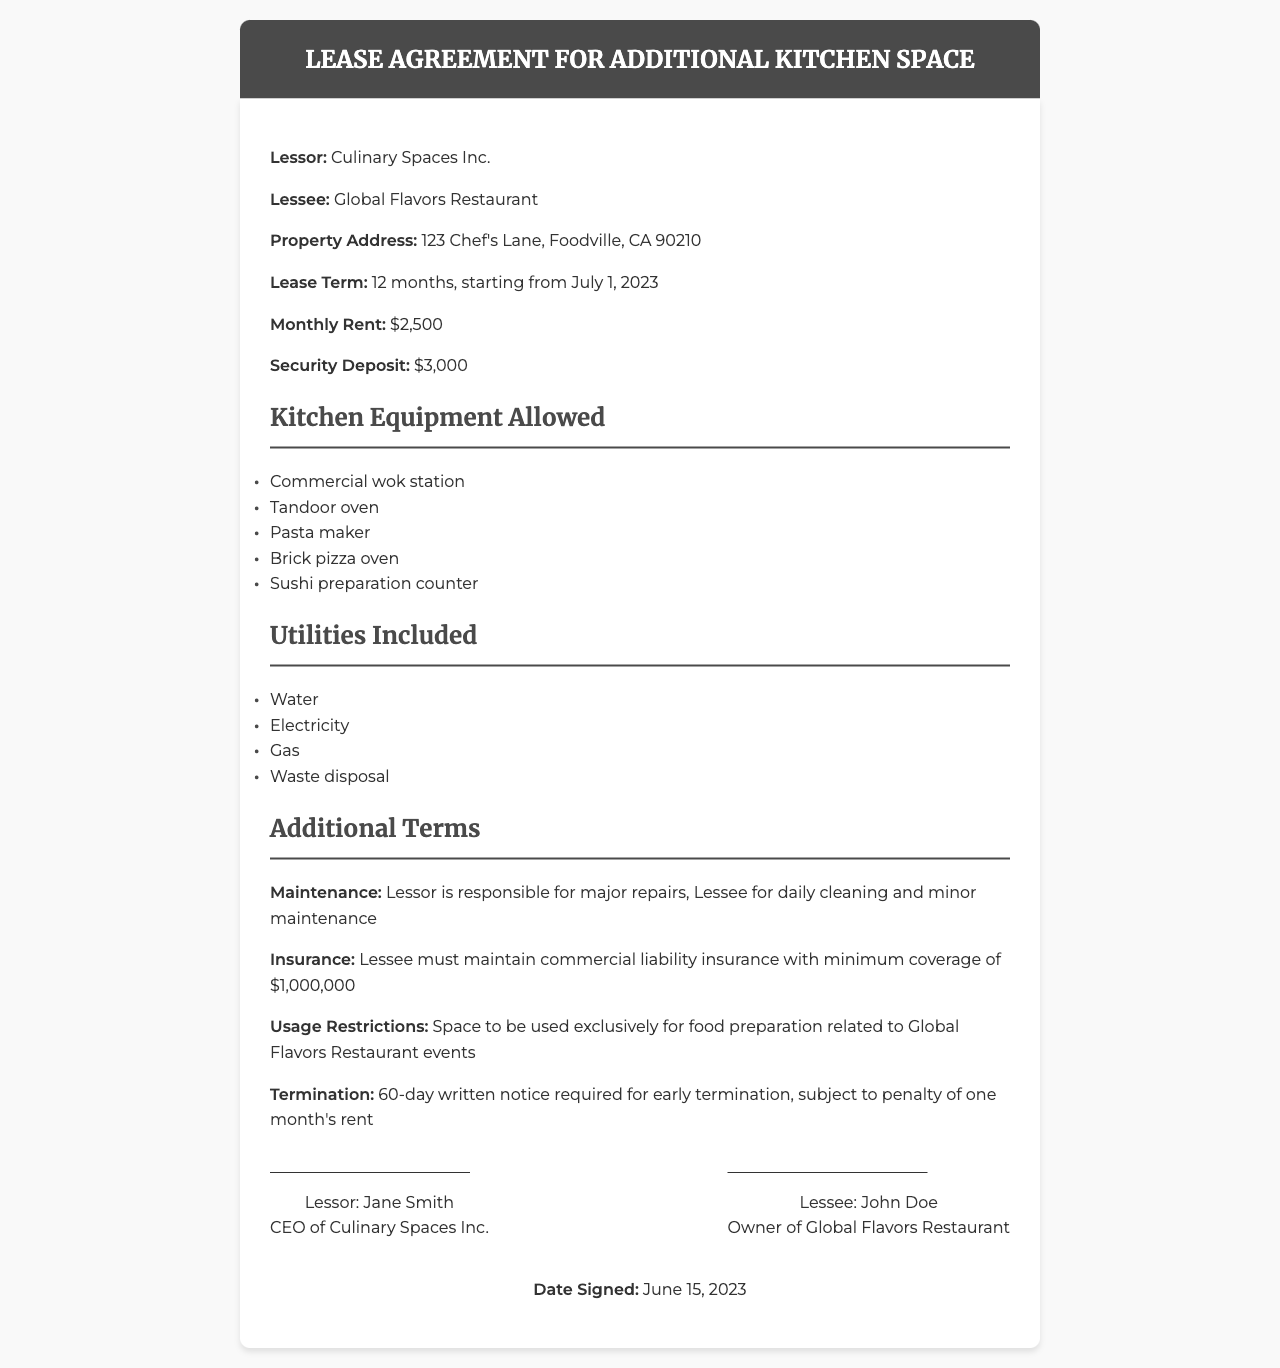What is the name of the lessor? The lessor is identified as Culinary Spaces Inc. in the document.
Answer: Culinary Spaces Inc What is the monthly rent amount? The monthly rent stated in the document is specified as $2,500.
Answer: $2,500 What is the security deposit required? The document specifies that the security deposit is set at $3,000.
Answer: $3,000 What is the lease term duration? The lease term is noted as 12 months in the document.
Answer: 12 months What type of oven is allowed in the kitchen equipment? The document lists a Tandoor oven as one of the permitted kitchen equipment.
Answer: Tandoor oven Who is responsible for major repairs? According to the document, the lessor is responsible for major repairs.
Answer: Lessor What is the minimum commercial liability insurance coverage required? The required minimum coverage for commercial liability insurance is noted as $1,000,000.
Answer: $1,000,000 Where is the property located? The property address is given as 123 Chef's Lane, Foodville, CA 90210.
Answer: 123 Chef's Lane, Foodville, CA 90210 How many days' notice is required for early termination? The document states that a 60-day written notice is necessary for early termination.
Answer: 60 days 